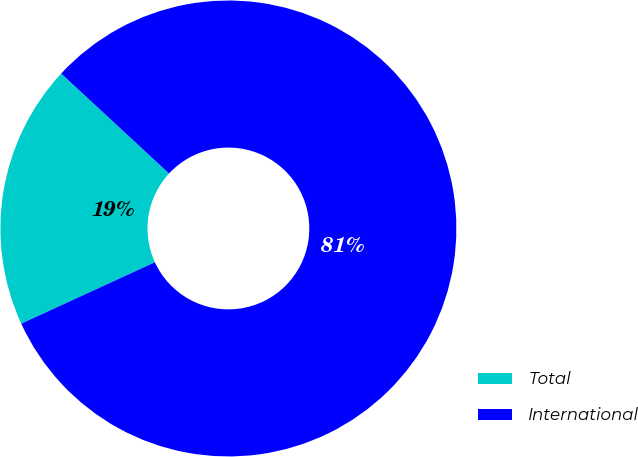Convert chart to OTSL. <chart><loc_0><loc_0><loc_500><loc_500><pie_chart><fcel>Total<fcel>International<nl><fcel>18.75%<fcel>81.25%<nl></chart> 